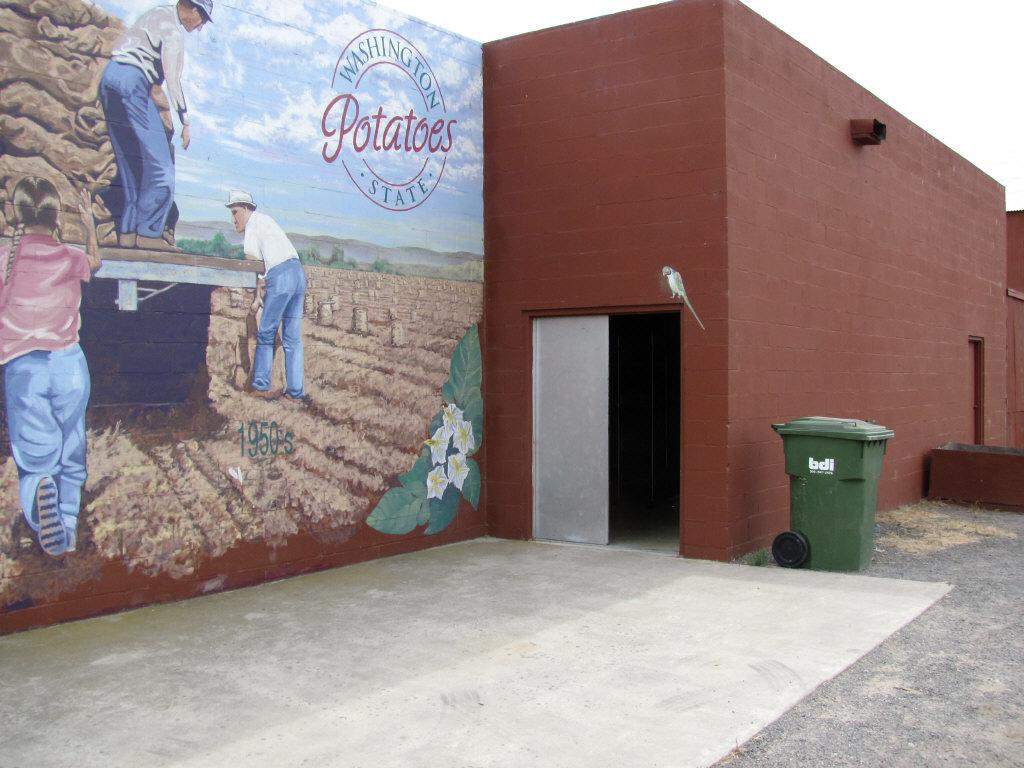<image>
Relay a brief, clear account of the picture shown. Drawing on a wall which says Potatoes on it. 